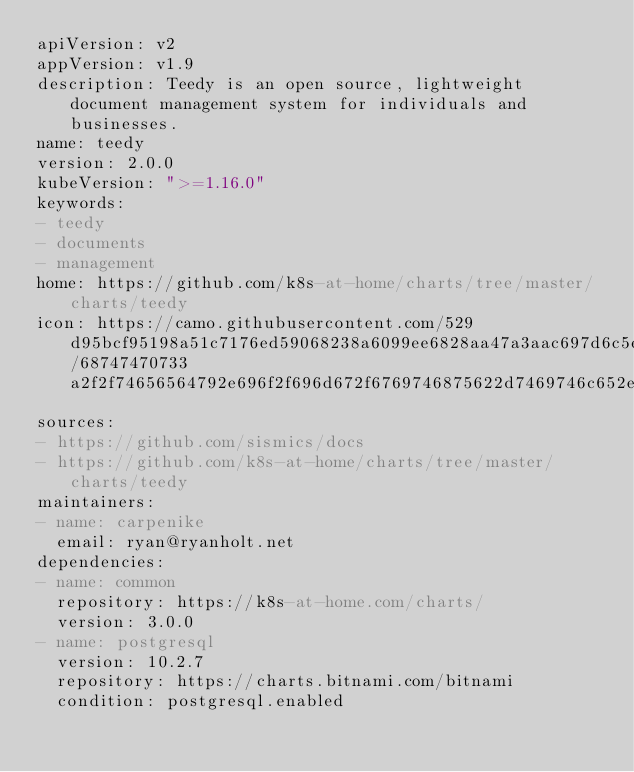<code> <loc_0><loc_0><loc_500><loc_500><_YAML_>apiVersion: v2
appVersion: v1.9
description: Teedy is an open source, lightweight document management system for individuals and businesses.
name: teedy
version: 2.0.0
kubeVersion: ">=1.16.0"
keywords:
- teedy
- documents
- management
home: https://github.com/k8s-at-home/charts/tree/master/charts/teedy
icon: https://camo.githubusercontent.com/529d95bcf95198a51c7176ed59068238a6099ee6828aa47a3aac697d6c5ee5f4/68747470733a2f2f74656564792e696f2f696d672f6769746875622d7469746c652e706e67
sources:
- https://github.com/sismics/docs
- https://github.com/k8s-at-home/charts/tree/master/charts/teedy
maintainers:
- name: carpenike
  email: ryan@ryanholt.net
dependencies:
- name: common
  repository: https://k8s-at-home.com/charts/
  version: 3.0.0
- name: postgresql
  version: 10.2.7
  repository: https://charts.bitnami.com/bitnami
  condition: postgresql.enabled
</code> 